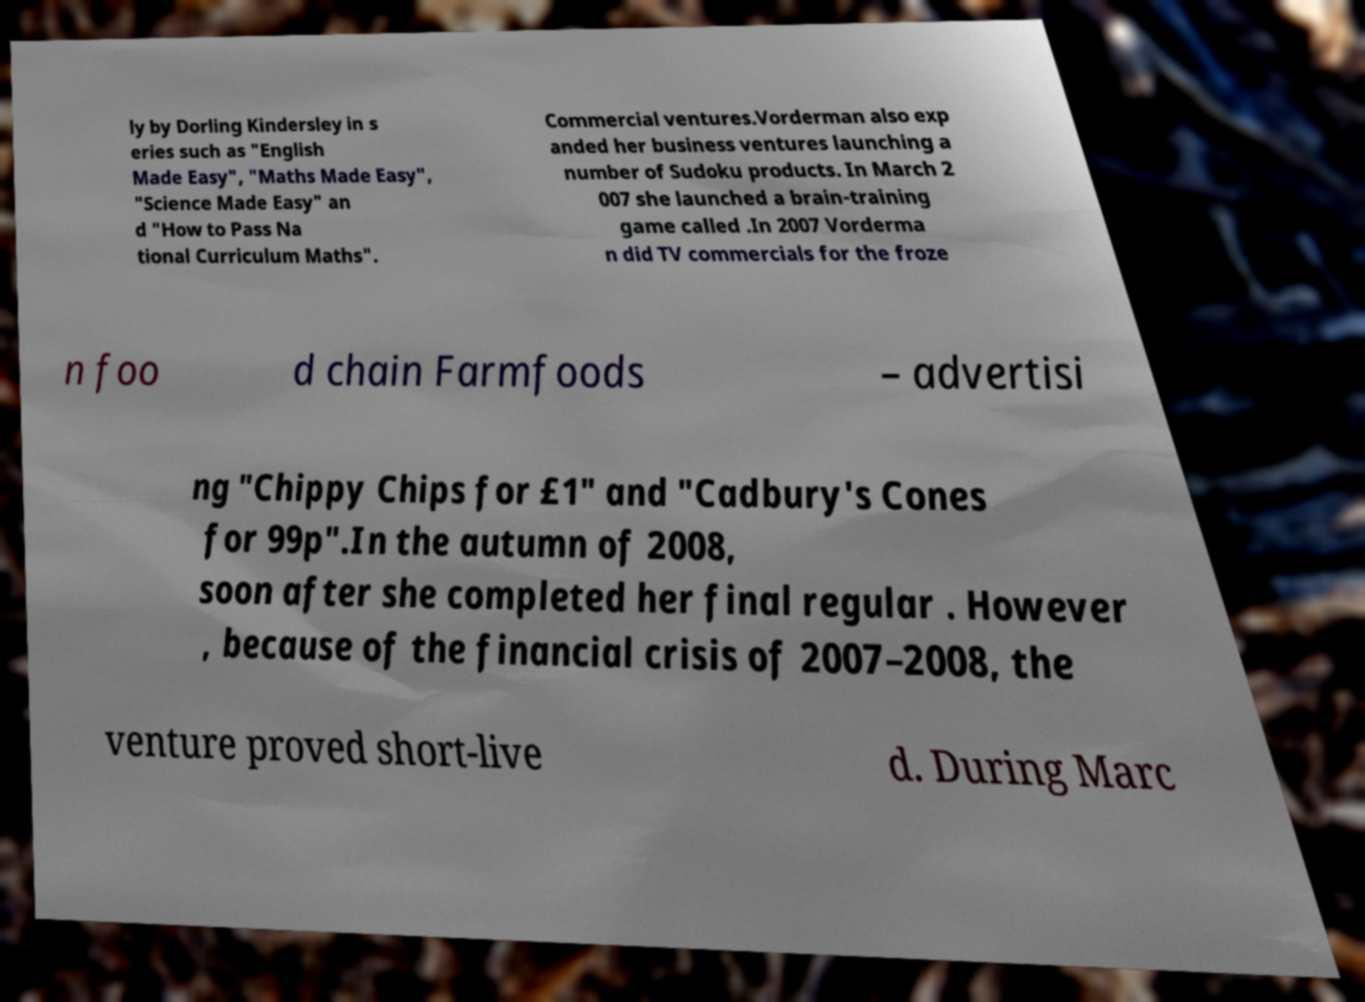I need the written content from this picture converted into text. Can you do that? ly by Dorling Kindersley in s eries such as "English Made Easy", "Maths Made Easy", "Science Made Easy" an d "How to Pass Na tional Curriculum Maths". Commercial ventures.Vorderman also exp anded her business ventures launching a number of Sudoku products. In March 2 007 she launched a brain-training game called .In 2007 Vorderma n did TV commercials for the froze n foo d chain Farmfoods – advertisi ng "Chippy Chips for £1" and "Cadbury's Cones for 99p".In the autumn of 2008, soon after she completed her final regular . However , because of the financial crisis of 2007–2008, the venture proved short-live d. During Marc 